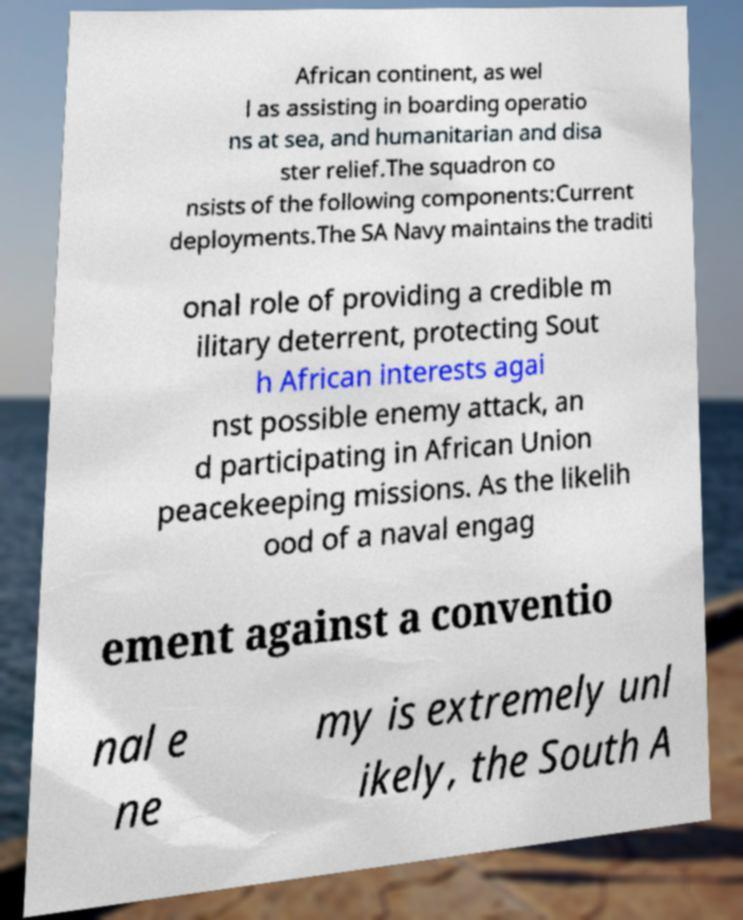Can you accurately transcribe the text from the provided image for me? African continent, as wel l as assisting in boarding operatio ns at sea, and humanitarian and disa ster relief.The squadron co nsists of the following components:Current deployments.The SA Navy maintains the traditi onal role of providing a credible m ilitary deterrent, protecting Sout h African interests agai nst possible enemy attack, an d participating in African Union peacekeeping missions. As the likelih ood of a naval engag ement against a conventio nal e ne my is extremely unl ikely, the South A 